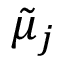<formula> <loc_0><loc_0><loc_500><loc_500>{ \tilde { \mu } _ { j } }</formula> 